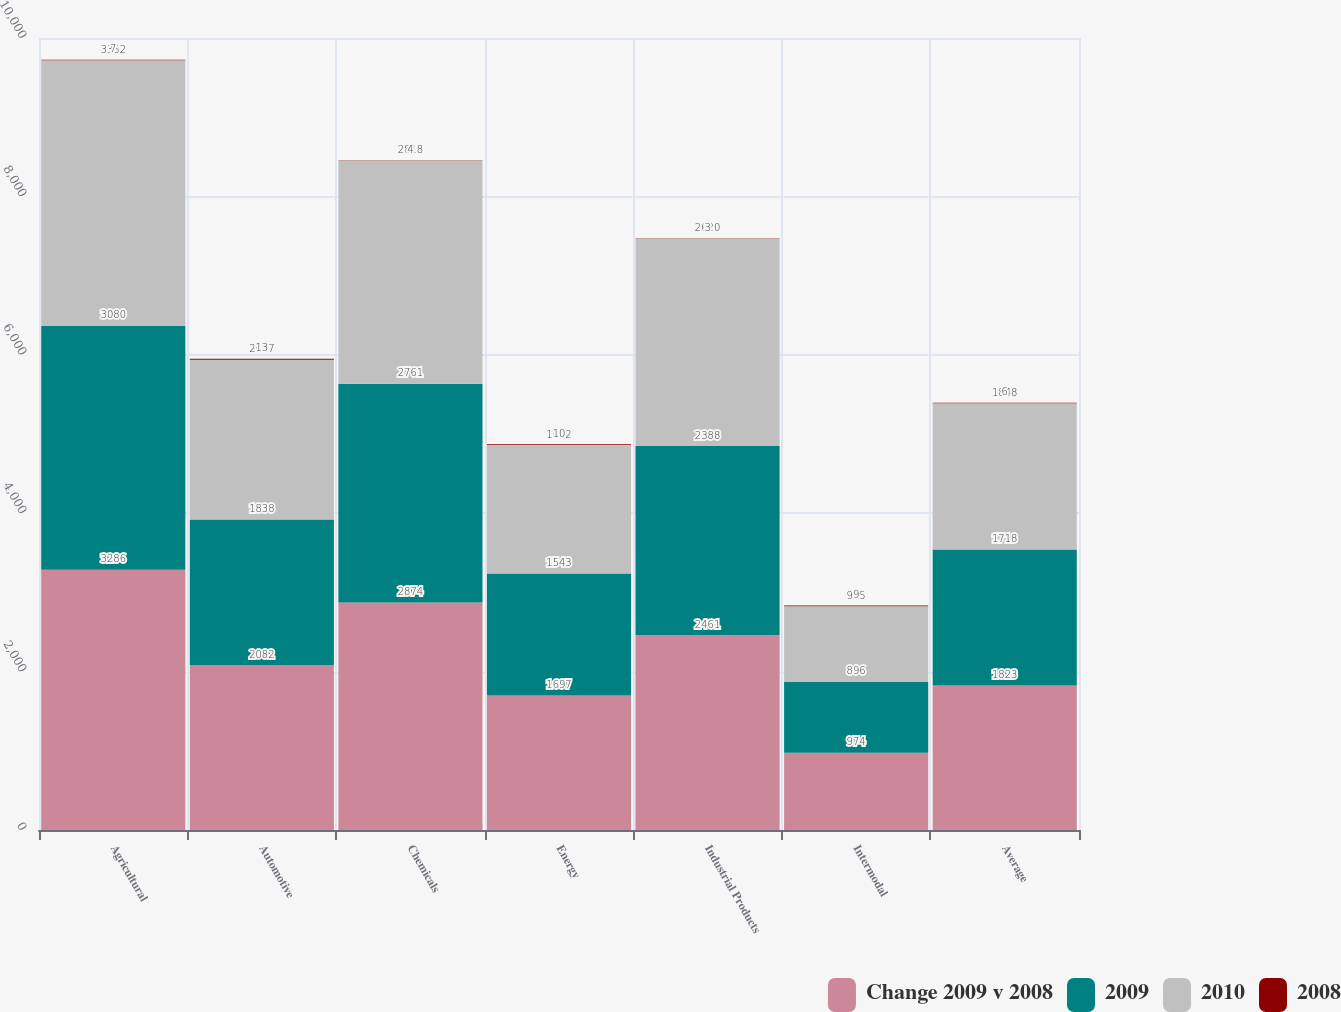<chart> <loc_0><loc_0><loc_500><loc_500><stacked_bar_chart><ecel><fcel>Agricultural<fcel>Automotive<fcel>Chemicals<fcel>Energy<fcel>Industrial Products<fcel>Intermodal<fcel>Average<nl><fcel>Change 2009 v 2008<fcel>3286<fcel>2082<fcel>2874<fcel>1697<fcel>2461<fcel>974<fcel>1823<nl><fcel>2009<fcel>3080<fcel>1838<fcel>2761<fcel>1543<fcel>2388<fcel>896<fcel>1718<nl><fcel>2010<fcel>3352<fcel>2017<fcel>2818<fcel>1622<fcel>2620<fcel>955<fcel>1848<nl><fcel>2008<fcel>7<fcel>13<fcel>4<fcel>10<fcel>3<fcel>9<fcel>6<nl></chart> 